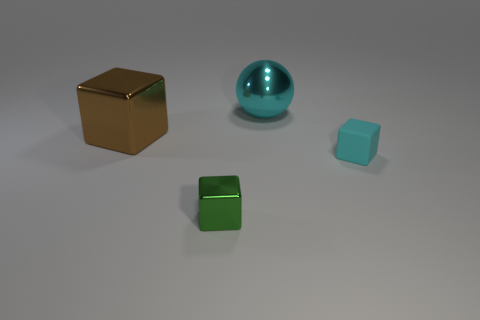Is there any other thing that has the same shape as the big cyan thing?
Make the answer very short. No. Is the number of large cyan metal spheres that are behind the brown object the same as the number of brown shiny blocks?
Offer a terse response. Yes. What number of things are either big gray rubber spheres or brown objects?
Keep it short and to the point. 1. There is a small green object that is the same material as the cyan sphere; what is its shape?
Provide a succinct answer. Cube. There is a object that is right of the cyan object behind the big brown cube; how big is it?
Provide a short and direct response. Small. How many tiny objects are either cyan cylinders or green blocks?
Your answer should be compact. 1. What number of other objects are the same color as the large sphere?
Your answer should be very brief. 1. Is the size of the block that is on the right side of the green metal block the same as the metallic block to the left of the tiny green object?
Provide a succinct answer. No. Does the large brown object have the same material as the cyan object right of the large cyan metal sphere?
Your response must be concise. No. Is the number of large cyan balls that are in front of the big sphere greater than the number of metallic balls left of the brown shiny block?
Keep it short and to the point. No. 